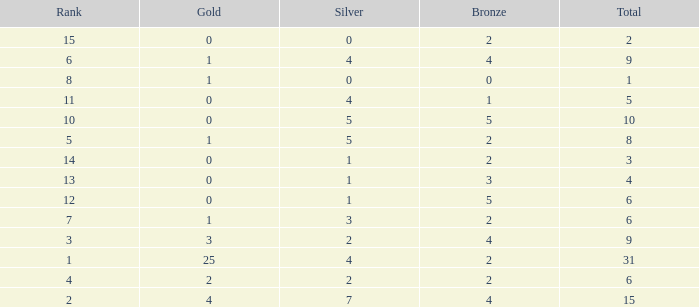What is the highest rank of the medal total less than 15, more than 2 bronzes, 0 gold and 1 silver? 13.0. 